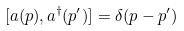Convert formula to latex. <formula><loc_0><loc_0><loc_500><loc_500>[ a ( { p } ) , a ^ { \dagger } ( { { p } ^ { \prime } } ) ] = \delta { ( { p } - { p } ^ { \prime } ) }</formula> 